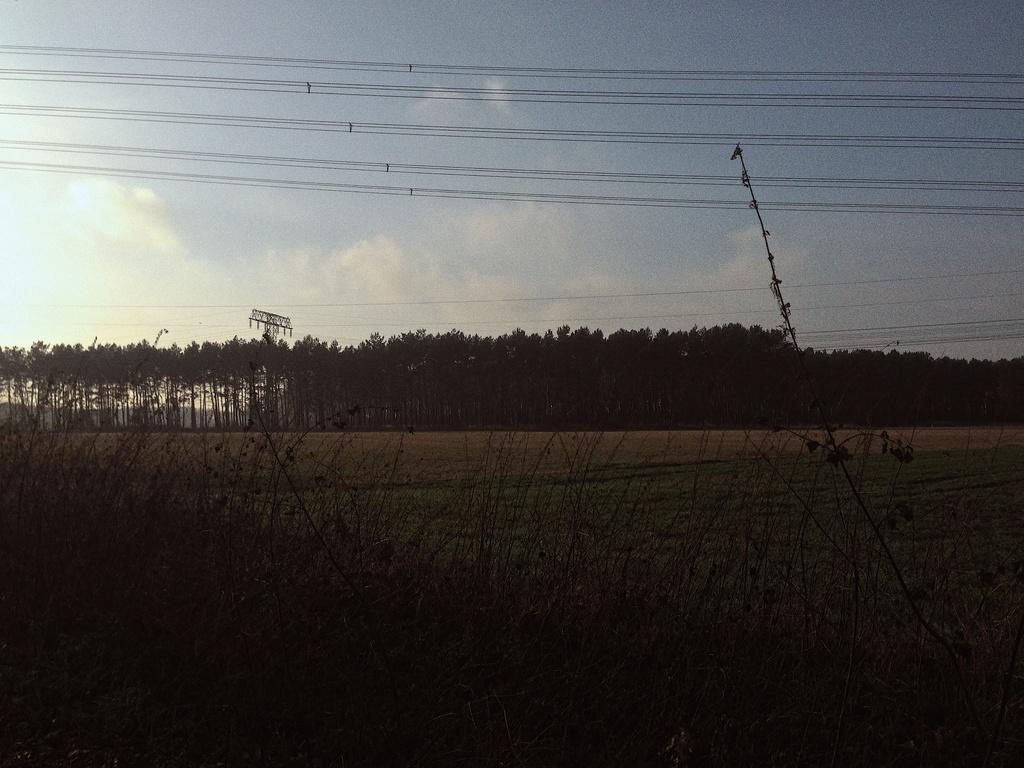Can you describe this image briefly? In this image there are some trees in the bottom of this image and there is a sky on the top of this image. There is a current pole on the left side of this image. There are some wires as we can see on the top of this image. 